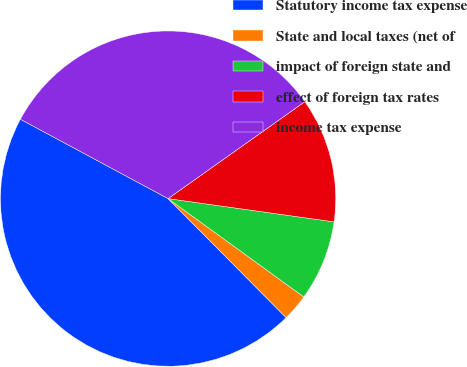Convert chart to OTSL. <chart><loc_0><loc_0><loc_500><loc_500><pie_chart><fcel>Statutory income tax expense<fcel>State and local taxes (net of<fcel>impact of foreign state and<fcel>effect of foreign tax rates<fcel>income tax expense<nl><fcel>45.28%<fcel>2.59%<fcel>7.76%<fcel>12.03%<fcel>32.34%<nl></chart> 